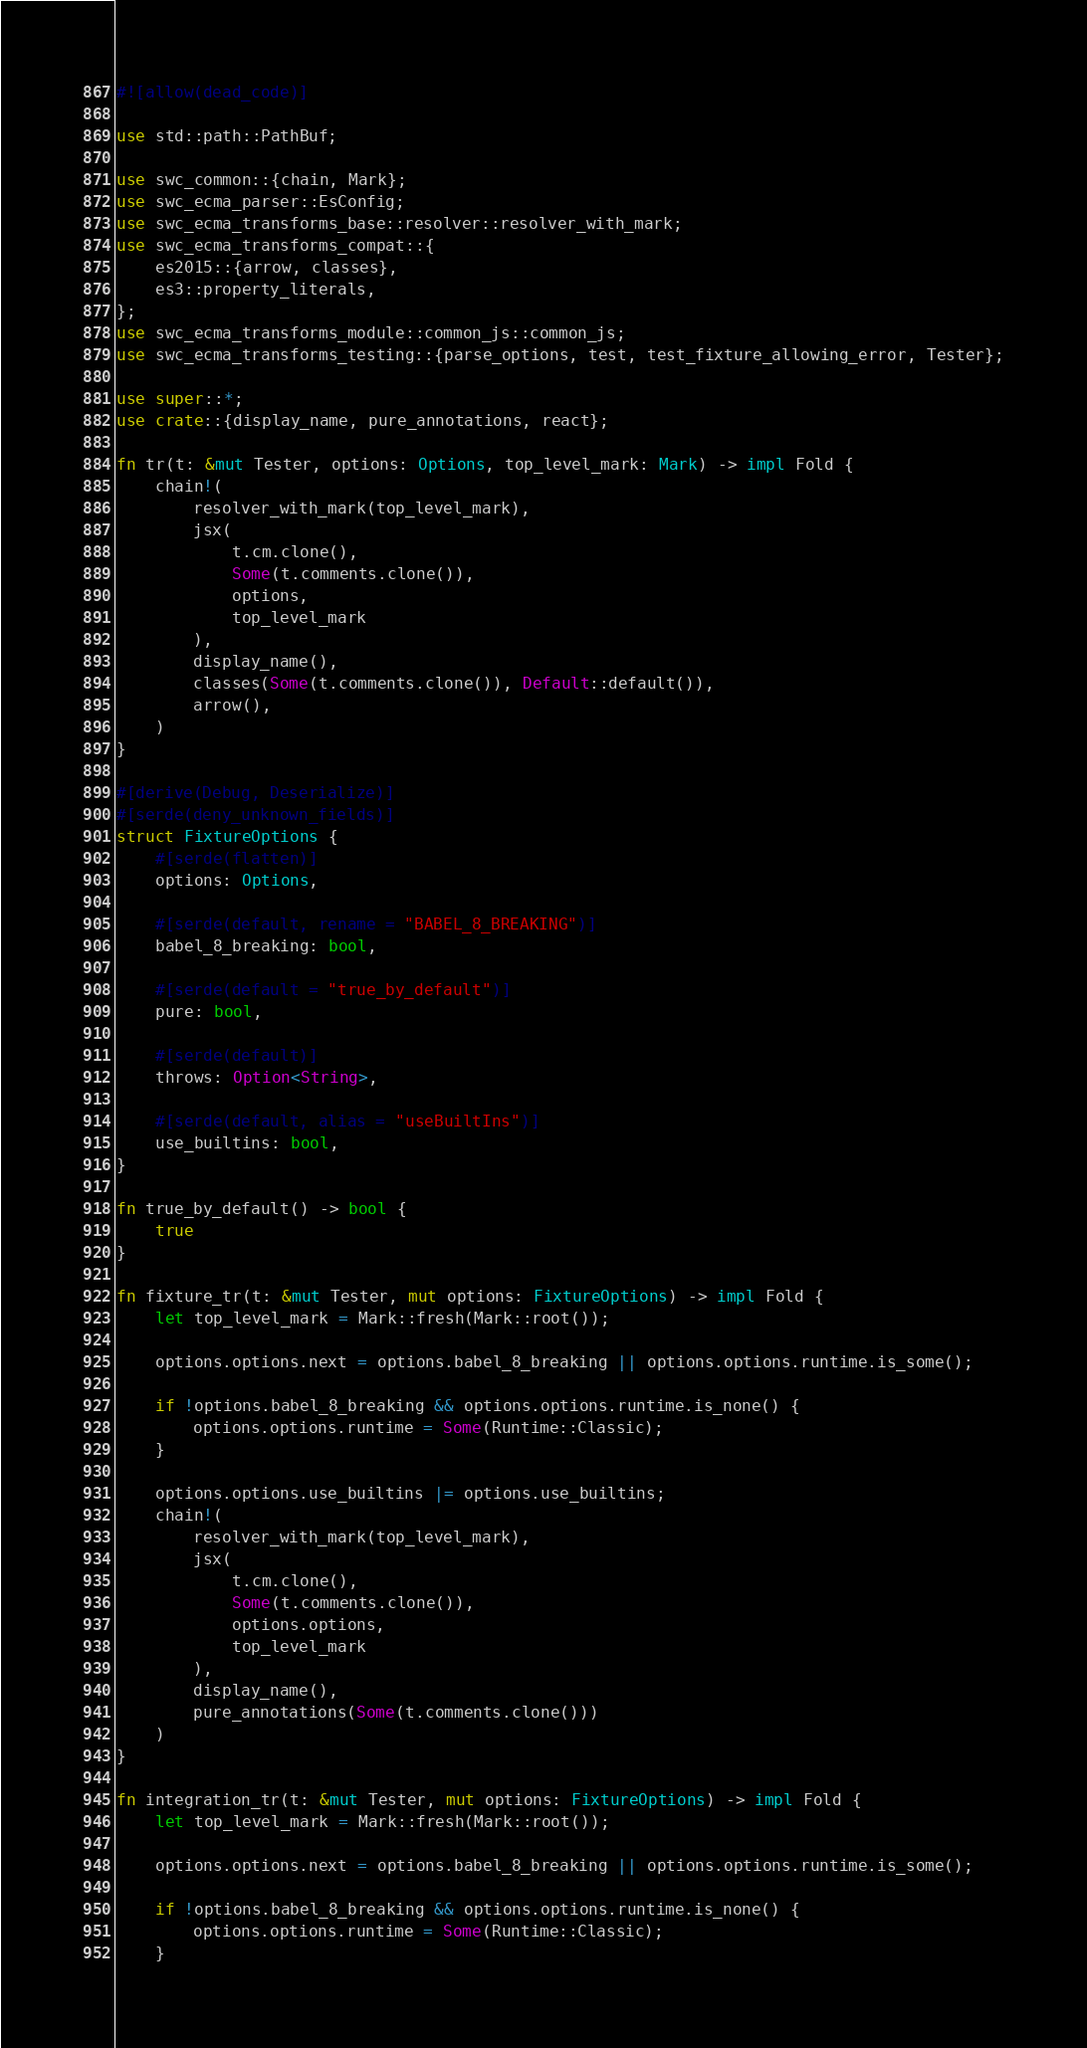<code> <loc_0><loc_0><loc_500><loc_500><_Rust_>#![allow(dead_code)]

use std::path::PathBuf;

use swc_common::{chain, Mark};
use swc_ecma_parser::EsConfig;
use swc_ecma_transforms_base::resolver::resolver_with_mark;
use swc_ecma_transforms_compat::{
    es2015::{arrow, classes},
    es3::property_literals,
};
use swc_ecma_transforms_module::common_js::common_js;
use swc_ecma_transforms_testing::{parse_options, test, test_fixture_allowing_error, Tester};

use super::*;
use crate::{display_name, pure_annotations, react};

fn tr(t: &mut Tester, options: Options, top_level_mark: Mark) -> impl Fold {
    chain!(
        resolver_with_mark(top_level_mark),
        jsx(
            t.cm.clone(),
            Some(t.comments.clone()),
            options,
            top_level_mark
        ),
        display_name(),
        classes(Some(t.comments.clone()), Default::default()),
        arrow(),
    )
}

#[derive(Debug, Deserialize)]
#[serde(deny_unknown_fields)]
struct FixtureOptions {
    #[serde(flatten)]
    options: Options,

    #[serde(default, rename = "BABEL_8_BREAKING")]
    babel_8_breaking: bool,

    #[serde(default = "true_by_default")]
    pure: bool,

    #[serde(default)]
    throws: Option<String>,

    #[serde(default, alias = "useBuiltIns")]
    use_builtins: bool,
}

fn true_by_default() -> bool {
    true
}

fn fixture_tr(t: &mut Tester, mut options: FixtureOptions) -> impl Fold {
    let top_level_mark = Mark::fresh(Mark::root());

    options.options.next = options.babel_8_breaking || options.options.runtime.is_some();

    if !options.babel_8_breaking && options.options.runtime.is_none() {
        options.options.runtime = Some(Runtime::Classic);
    }

    options.options.use_builtins |= options.use_builtins;
    chain!(
        resolver_with_mark(top_level_mark),
        jsx(
            t.cm.clone(),
            Some(t.comments.clone()),
            options.options,
            top_level_mark
        ),
        display_name(),
        pure_annotations(Some(t.comments.clone()))
    )
}

fn integration_tr(t: &mut Tester, mut options: FixtureOptions) -> impl Fold {
    let top_level_mark = Mark::fresh(Mark::root());

    options.options.next = options.babel_8_breaking || options.options.runtime.is_some();

    if !options.babel_8_breaking && options.options.runtime.is_none() {
        options.options.runtime = Some(Runtime::Classic);
    }
</code> 